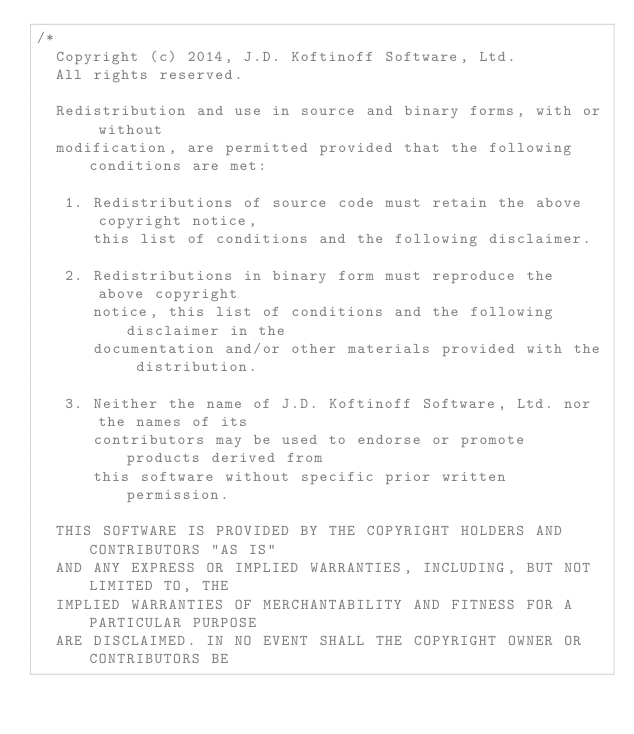Convert code to text. <code><loc_0><loc_0><loc_500><loc_500><_C++_>/*
  Copyright (c) 2014, J.D. Koftinoff Software, Ltd.
  All rights reserved.

  Redistribution and use in source and binary forms, with or without
  modification, are permitted provided that the following conditions are met:

   1. Redistributions of source code must retain the above copyright notice,
      this list of conditions and the following disclaimer.

   2. Redistributions in binary form must reproduce the above copyright
      notice, this list of conditions and the following disclaimer in the
      documentation and/or other materials provided with the distribution.

   3. Neither the name of J.D. Koftinoff Software, Ltd. nor the names of its
      contributors may be used to endorse or promote products derived from
      this software without specific prior written permission.

  THIS SOFTWARE IS PROVIDED BY THE COPYRIGHT HOLDERS AND CONTRIBUTORS "AS IS"
  AND ANY EXPRESS OR IMPLIED WARRANTIES, INCLUDING, BUT NOT LIMITED TO, THE
  IMPLIED WARRANTIES OF MERCHANTABILITY AND FITNESS FOR A PARTICULAR PURPOSE
  ARE DISCLAIMED. IN NO EVENT SHALL THE COPYRIGHT OWNER OR CONTRIBUTORS BE</code> 